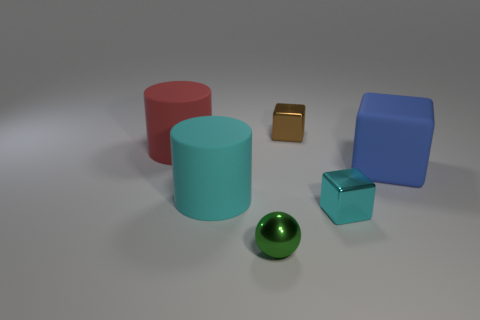What color is the cube that is made of the same material as the red thing?
Your answer should be compact. Blue. The large rubber object that is behind the large matte thing that is right of the thing in front of the small cyan block is what color?
Keep it short and to the point. Red. What number of spheres are either large gray things or small things?
Keep it short and to the point. 1. Do the ball and the shiny cube that is in front of the blue rubber block have the same color?
Keep it short and to the point. No. The sphere is what color?
Your answer should be compact. Green. How many things are big matte cylinders or big cyan objects?
Your answer should be very brief. 2. There is a cyan object that is the same size as the green shiny object; what is its material?
Your answer should be compact. Metal. What is the size of the block to the left of the cyan block?
Offer a very short reply. Small. What is the tiny green ball made of?
Your answer should be very brief. Metal. How many objects are metallic things that are behind the green sphere or objects that are to the right of the cyan metallic cube?
Your response must be concise. 3. 